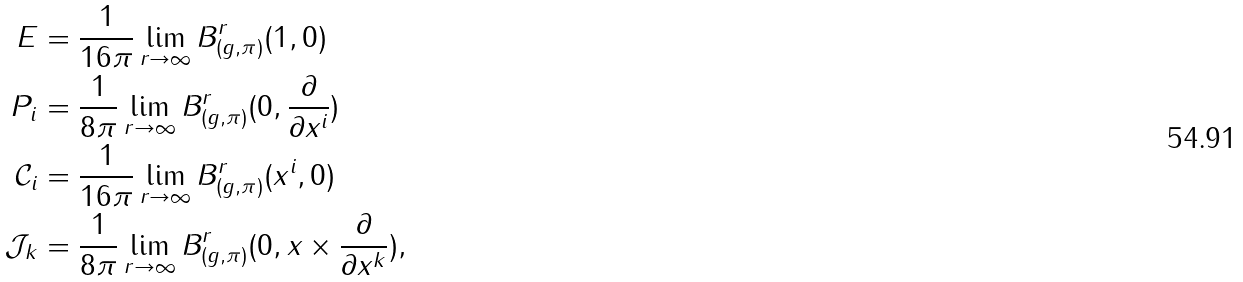<formula> <loc_0><loc_0><loc_500><loc_500>E & = \frac { 1 } { 1 6 \pi } \lim _ { r \to \infty } B ^ { r } _ { ( g , \pi ) } ( 1 , 0 ) \\ P _ { i } & = \frac { 1 } { 8 \pi } \lim _ { r \to \infty } B ^ { r } _ { ( g , \pi ) } ( 0 , \frac { \partial } { \partial x ^ { i } } ) \\ \mathcal { C } _ { i } & = \frac { 1 } { 1 6 \pi } \lim _ { r \rightarrow \infty } B ^ { r } _ { ( g , \pi ) } ( x ^ { i } , 0 ) \\ \mathcal { J } _ { k } & = \frac { 1 } { 8 \pi } \lim _ { r \rightarrow \infty } B ^ { r } _ { ( g , \pi ) } ( 0 , x \times \frac { \partial } { \partial x ^ { k } } ) ,</formula> 